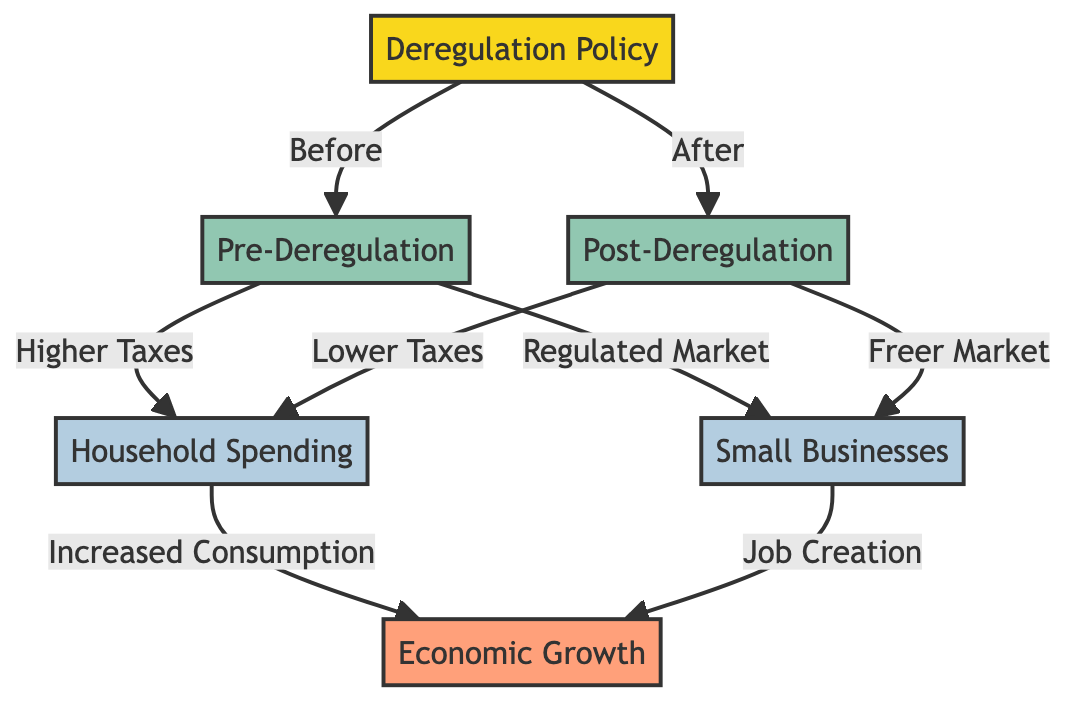What is the main policy depicted in the diagram? The main policy depicted is "Deregulation Policy," as it is the starting point of the flowchart, indicating the policies that affect consumer spending patterns in Quebec.
Answer: Deregulation Policy What is the effect of post-deregulation on household spending? After deregulation, the diagram shows the impact of "Lower Taxes" on household spending, suggesting that as taxes decrease, household spending increases.
Answer: Lower Taxes How many phases are represented in the diagram? The diagram includes two phases: "Pre-Deregulation" and "Post-Deregulation," reflecting the timeframes before and after the deregulation policy was implemented.
Answer: 2 What is the relationship between small businesses and economic growth post-deregulation? The diagram indicates that post-deregulation leads to a "Freer Market," which is associated with "Job Creation" in small businesses, contributing to overall economic growth.
Answer: Job Creation Which factors lead to increased consumption according to the diagram? The diagram states that "Household Spending" increases consumption, showing the direct impact of taxes and regulated markets on consumer behavior before deregulation.
Answer: Increased Consumption What connects household spending to economic growth in the diagram? The connection shown is that "Increased Consumption" from household spending directly affects "Economic Growth," highlighting the relationship between these two factors.
Answer: Increased Consumption How does the market structure change from pre- to post-deregulation for small businesses? The diagram illustrates that the market changes from a "Regulated Market" pre-deregulation to a "Freer Market" post-deregulation, highlighting the shift in economic conditions for small businesses.
Answer: Freer Market What is the overall outcome of deregulation as indicated in the diagram? The overall outcome of the deregulation policy, as illustrated in the diagram, is "Economic Growth," demonstrating the cumulative effects of changes in taxation and market regulation.
Answer: Economic Growth 